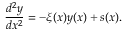Convert formula to latex. <formula><loc_0><loc_0><loc_500><loc_500>\frac { d ^ { 2 } y } { d x ^ { 2 } } = - \xi ( x ) y ( x ) + s ( x ) .</formula> 